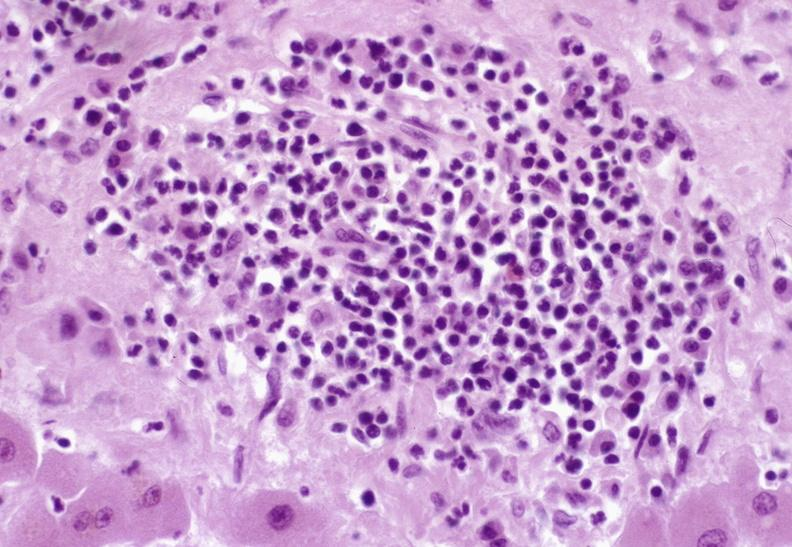s liver present?
Answer the question using a single word or phrase. Yes 